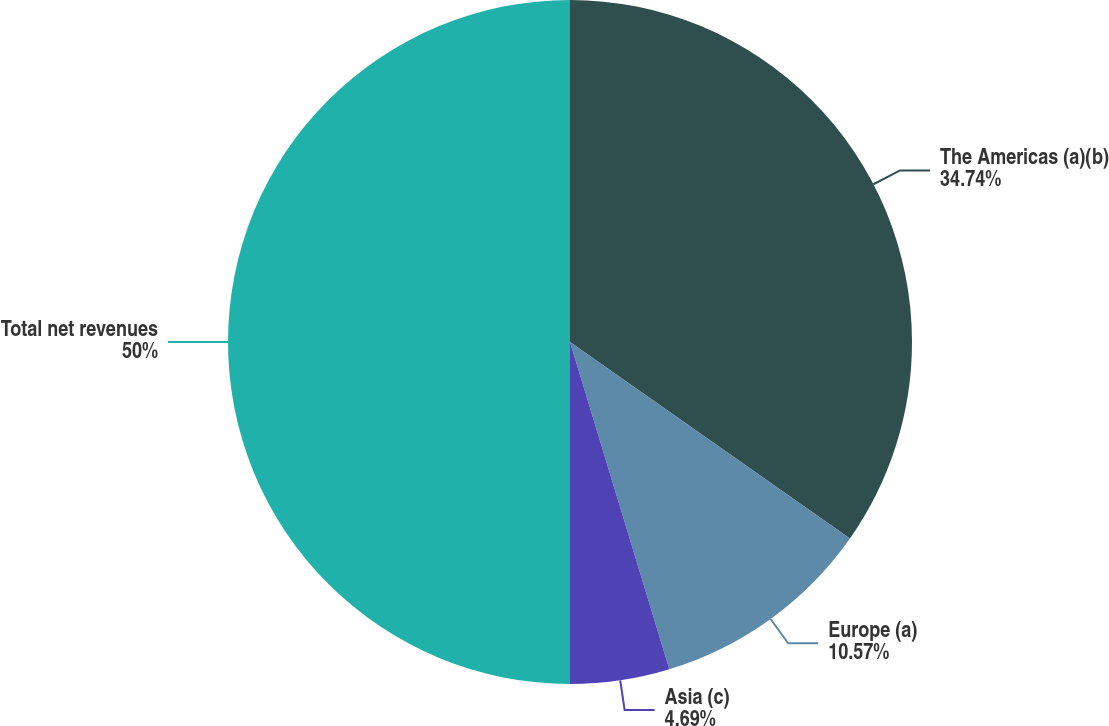<chart> <loc_0><loc_0><loc_500><loc_500><pie_chart><fcel>The Americas (a)(b)<fcel>Europe (a)<fcel>Asia (c)<fcel>Total net revenues<nl><fcel>34.74%<fcel>10.57%<fcel>4.69%<fcel>50.0%<nl></chart> 